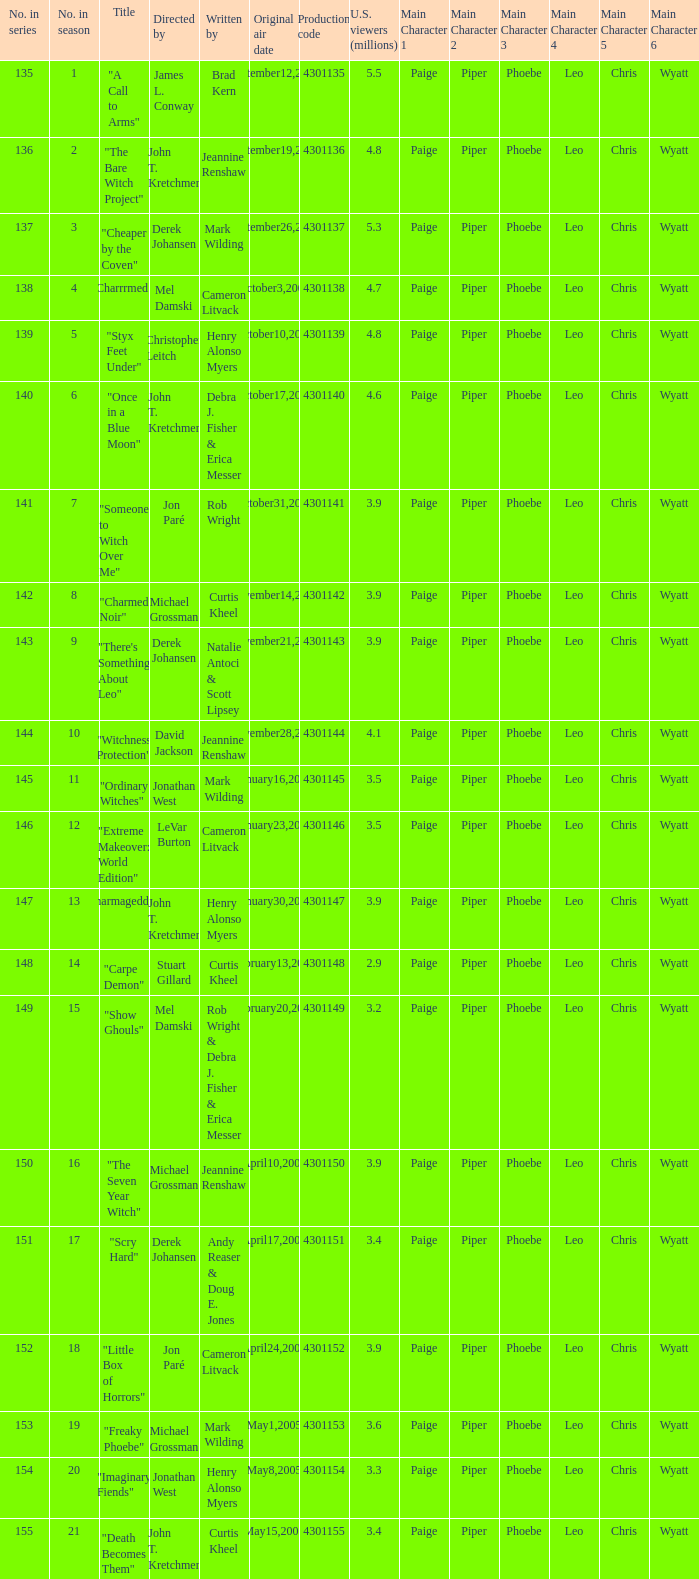In season number 3,  who were the writers? Mark Wilding. 